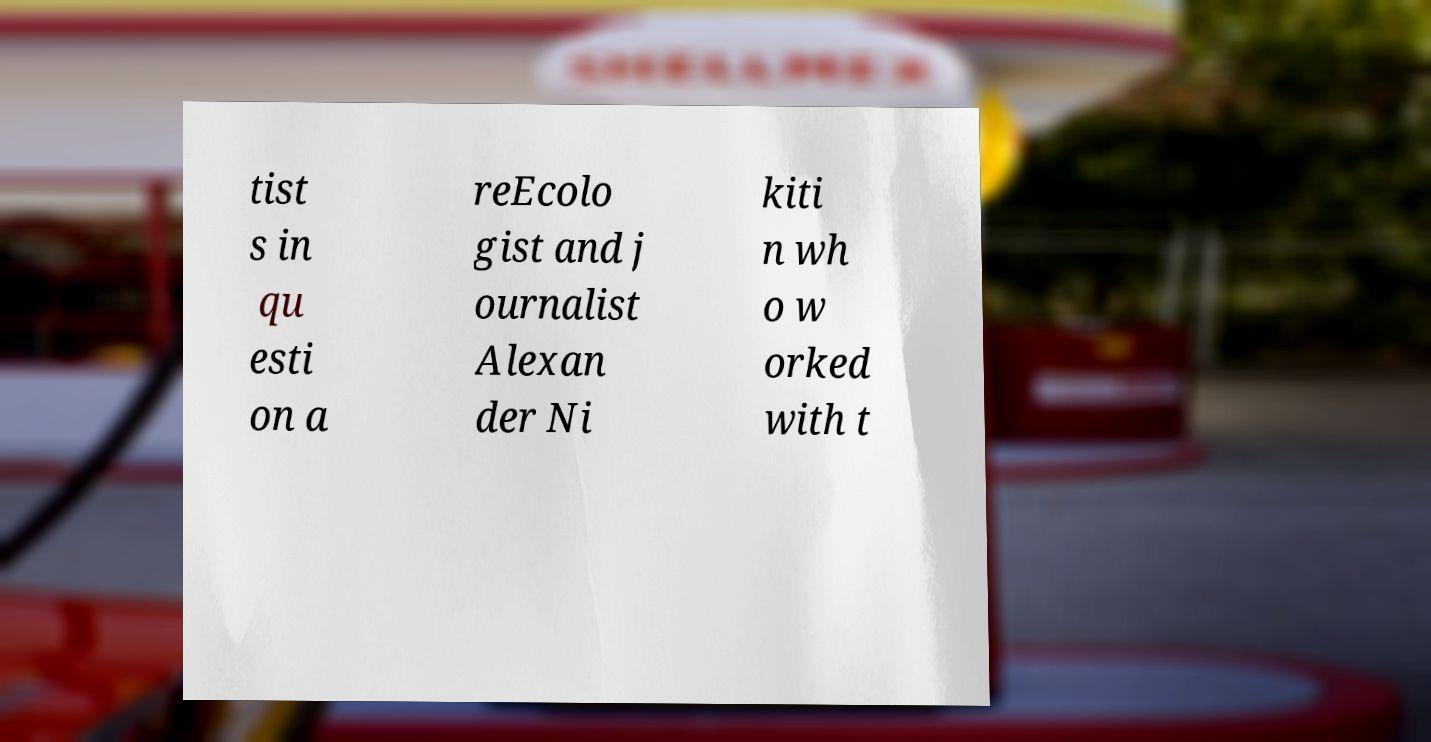Could you extract and type out the text from this image? tist s in qu esti on a reEcolo gist and j ournalist Alexan der Ni kiti n wh o w orked with t 